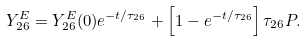<formula> <loc_0><loc_0><loc_500><loc_500>Y _ { 2 6 } ^ { E } = Y _ { 2 6 } ^ { E } ( 0 ) e ^ { - t / \tau _ { 2 6 } } + \left [ 1 - e ^ { - t / \tau _ { 2 6 } } \right ] \tau _ { 2 6 } P .</formula> 